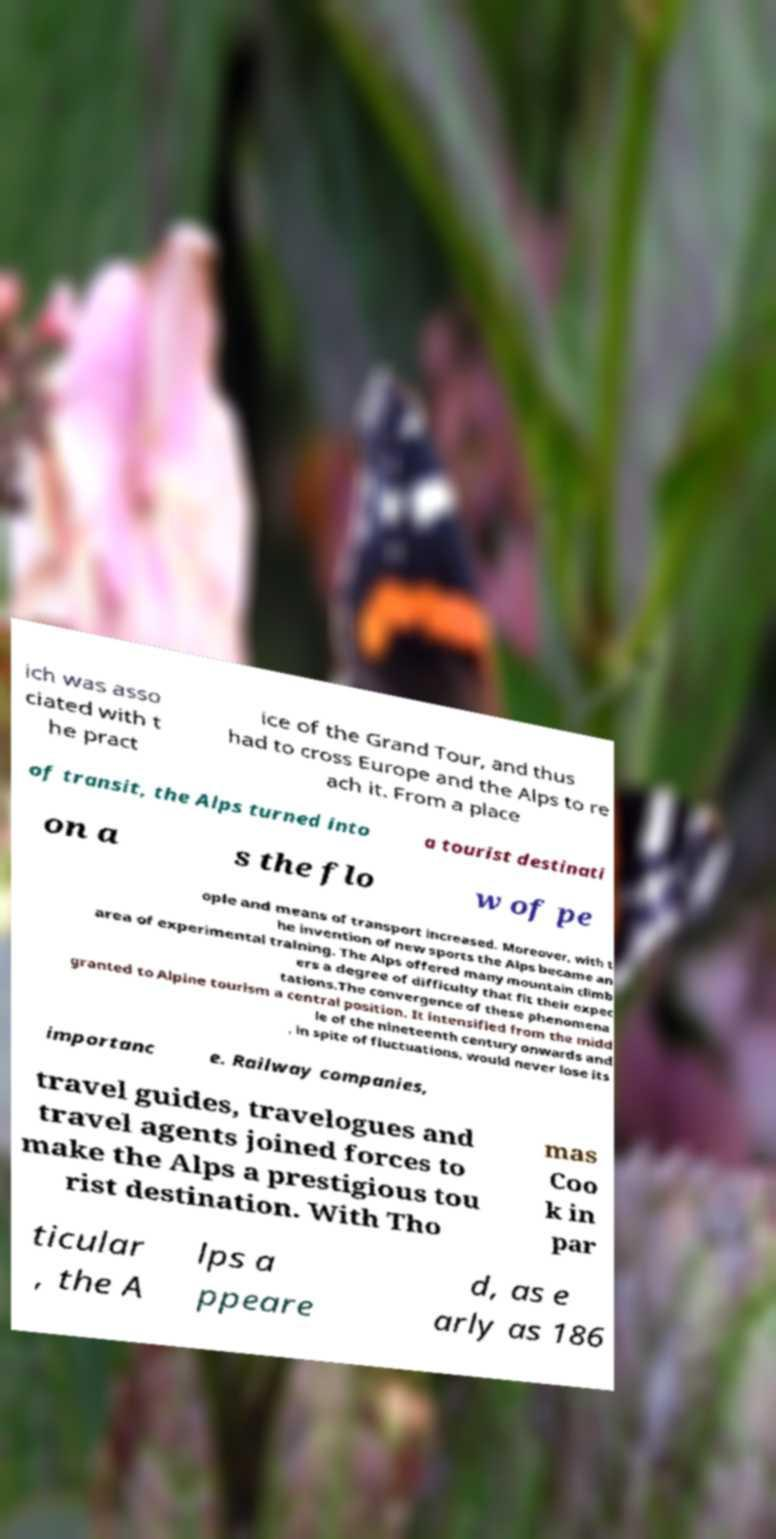Could you assist in decoding the text presented in this image and type it out clearly? ich was asso ciated with t he pract ice of the Grand Tour, and thus had to cross Europe and the Alps to re ach it. From a place of transit, the Alps turned into a tourist destinati on a s the flo w of pe ople and means of transport increased. Moreover, with t he invention of new sports the Alps became an area of experimental training. The Alps offered many mountain climb ers a degree of difficulty that fit their expec tations.The convergence of these phenomena granted to Alpine tourism a central position. It intensified from the midd le of the nineteenth century onwards and , in spite of fluctuations, would never lose its importanc e. Railway companies, travel guides, travelogues and travel agents joined forces to make the Alps a prestigious tou rist destination. With Tho mas Coo k in par ticular , the A lps a ppeare d, as e arly as 186 